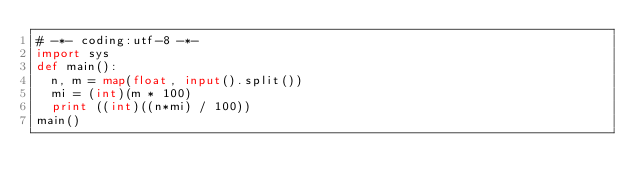Convert code to text. <code><loc_0><loc_0><loc_500><loc_500><_Python_># -*- coding:utf-8 -*-
import sys
def main():
  n, m = map(float, input().split())
  mi = (int)(m * 100)
  print ((int)((n*mi) / 100))
main()</code> 